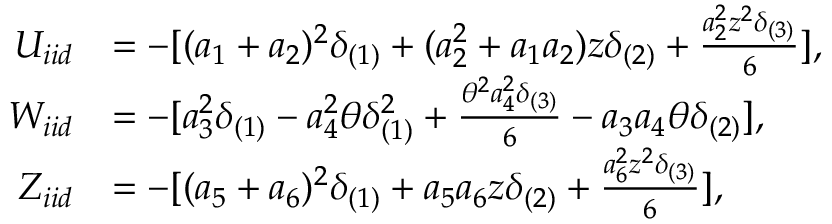<formula> <loc_0><loc_0><loc_500><loc_500>\begin{array} { r l } { U _ { i i d } } & { = - [ ( a _ { 1 } + a _ { 2 } ) ^ { 2 } \delta _ { ( 1 ) } + ( a _ { 2 } ^ { 2 } + a _ { 1 } a _ { 2 } ) z \delta _ { ( 2 ) } + \frac { a _ { 2 } ^ { 2 } z ^ { 2 } \delta _ { ( 3 ) } } { 6 } ] , } \\ { W _ { i i d } } & { = - [ a _ { 3 } ^ { 2 } \delta _ { ( 1 ) } - a _ { 4 } ^ { 2 } \theta \delta _ { ( 1 ) } ^ { 2 } + \frac { \theta ^ { 2 } a _ { 4 } ^ { 2 } \delta _ { ( 3 ) } } { 6 } - a _ { 3 } a _ { 4 } \theta \delta _ { ( 2 ) } ] , } \\ { Z _ { i i d } } & { = - [ ( a _ { 5 } + a _ { 6 } ) ^ { 2 } \delta _ { ( 1 ) } + a _ { 5 } a _ { 6 } z \delta _ { ( 2 ) } + \frac { a _ { 6 } ^ { 2 } z ^ { 2 } \delta _ { ( 3 ) } } { 6 } ] , } \end{array}</formula> 